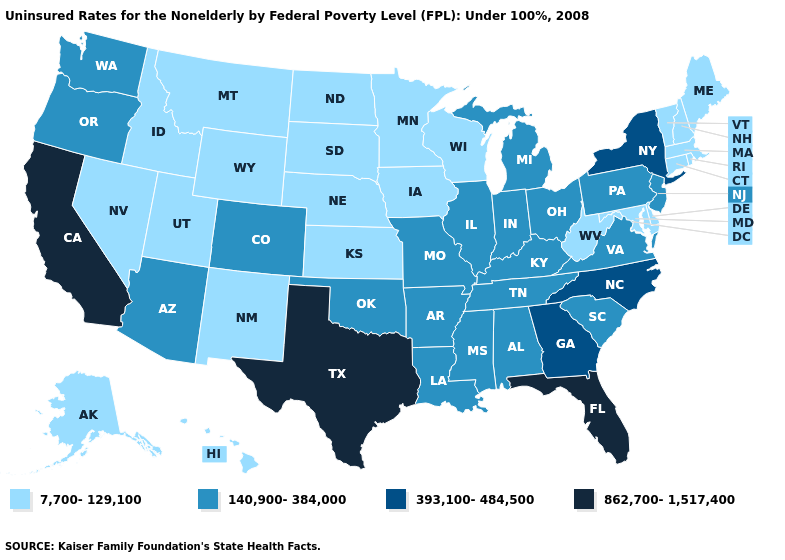Which states have the lowest value in the MidWest?
Quick response, please. Iowa, Kansas, Minnesota, Nebraska, North Dakota, South Dakota, Wisconsin. Name the states that have a value in the range 140,900-384,000?
Answer briefly. Alabama, Arizona, Arkansas, Colorado, Illinois, Indiana, Kentucky, Louisiana, Michigan, Mississippi, Missouri, New Jersey, Ohio, Oklahoma, Oregon, Pennsylvania, South Carolina, Tennessee, Virginia, Washington. Which states have the lowest value in the West?
Concise answer only. Alaska, Hawaii, Idaho, Montana, Nevada, New Mexico, Utah, Wyoming. Which states have the lowest value in the USA?
Quick response, please. Alaska, Connecticut, Delaware, Hawaii, Idaho, Iowa, Kansas, Maine, Maryland, Massachusetts, Minnesota, Montana, Nebraska, Nevada, New Hampshire, New Mexico, North Dakota, Rhode Island, South Dakota, Utah, Vermont, West Virginia, Wisconsin, Wyoming. Which states hav the highest value in the Northeast?
Be succinct. New York. Among the states that border Maine , which have the highest value?
Be succinct. New Hampshire. How many symbols are there in the legend?
Be succinct. 4. What is the highest value in the USA?
Be succinct. 862,700-1,517,400. Among the states that border Arizona , does California have the highest value?
Write a very short answer. Yes. Is the legend a continuous bar?
Give a very brief answer. No. What is the lowest value in the West?
Short answer required. 7,700-129,100. What is the value of Virginia?
Quick response, please. 140,900-384,000. Name the states that have a value in the range 7,700-129,100?
Concise answer only. Alaska, Connecticut, Delaware, Hawaii, Idaho, Iowa, Kansas, Maine, Maryland, Massachusetts, Minnesota, Montana, Nebraska, Nevada, New Hampshire, New Mexico, North Dakota, Rhode Island, South Dakota, Utah, Vermont, West Virginia, Wisconsin, Wyoming. Does Illinois have the same value as Nevada?
Give a very brief answer. No. Does the map have missing data?
Keep it brief. No. 